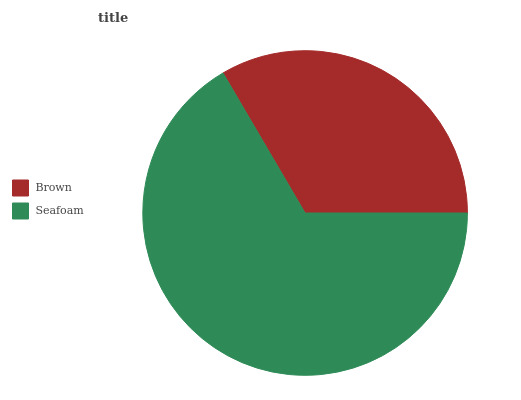Is Brown the minimum?
Answer yes or no. Yes. Is Seafoam the maximum?
Answer yes or no. Yes. Is Seafoam the minimum?
Answer yes or no. No. Is Seafoam greater than Brown?
Answer yes or no. Yes. Is Brown less than Seafoam?
Answer yes or no. Yes. Is Brown greater than Seafoam?
Answer yes or no. No. Is Seafoam less than Brown?
Answer yes or no. No. Is Seafoam the high median?
Answer yes or no. Yes. Is Brown the low median?
Answer yes or no. Yes. Is Brown the high median?
Answer yes or no. No. Is Seafoam the low median?
Answer yes or no. No. 